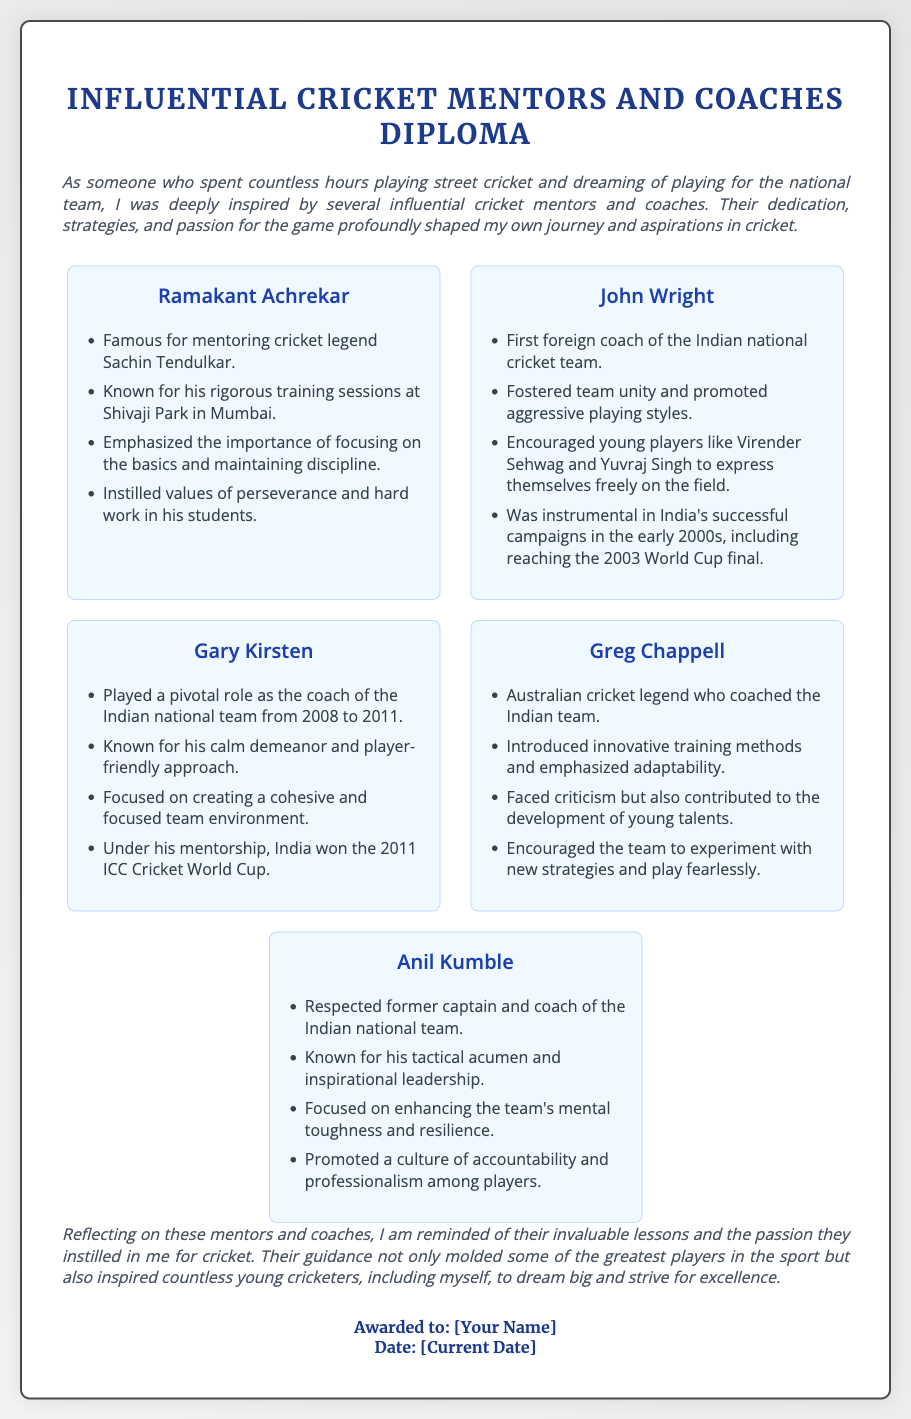What is the title of the document? The title is explicitly stated at the top of the document, indicating the subject matter.
Answer: Influential Cricket Mentors and Coaches Diploma Who is famous for mentoring Sachin Tendulkar? The document mentions Ramakant Achrekar in relation to Sachin Tendulkar.
Answer: Ramakant Achrekar Which coach won the ICC Cricket World Cup with India? The document specifies that Gary Kirsten coached India to victory in the World Cup.
Answer: Gary Kirsten What is John Wright known for in relation to the Indian team? The document highlights John's role as the first foreign coach of the Indian national cricket team.
Answer: First foreign coach Which mentor emphasized the importance of discipline? The document states that Ramakant Achrekar focused on maintaining discipline.
Answer: Ramakant Achrekar Who introduced innovative training methods to the Indian team? Greg Chappell is mentioned as the one who introduced innovative training methods.
Answer: Greg Chappell What year did Gary Kirsten coach the Indian national team? The document lists the duration of Gary Kirsten's coaching as 2008 to 2011.
Answer: 2008 to 2011 Which mentor is known for tactical acumen and inspirational leadership? The document identifies Anil Kumble as respected for these traits.
Answer: Anil Kumble What significant outcome did John Wright achieve during his coaching? The document notes that John Wright was instrumental in reaching the 2003 World Cup final.
Answer: Reaching the 2003 World Cup final 